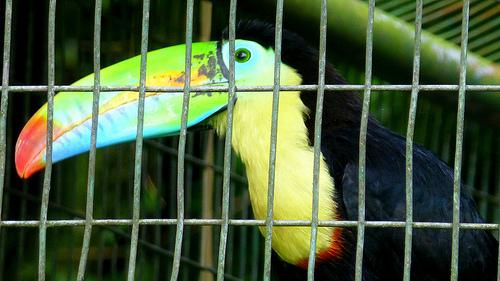Question: where is this photo taken?
Choices:
A. Beside the dining room table.
B. Outside behind a cage.
C. In the living room.
D. In the mountains.
Answer with the letter. Answer: B 